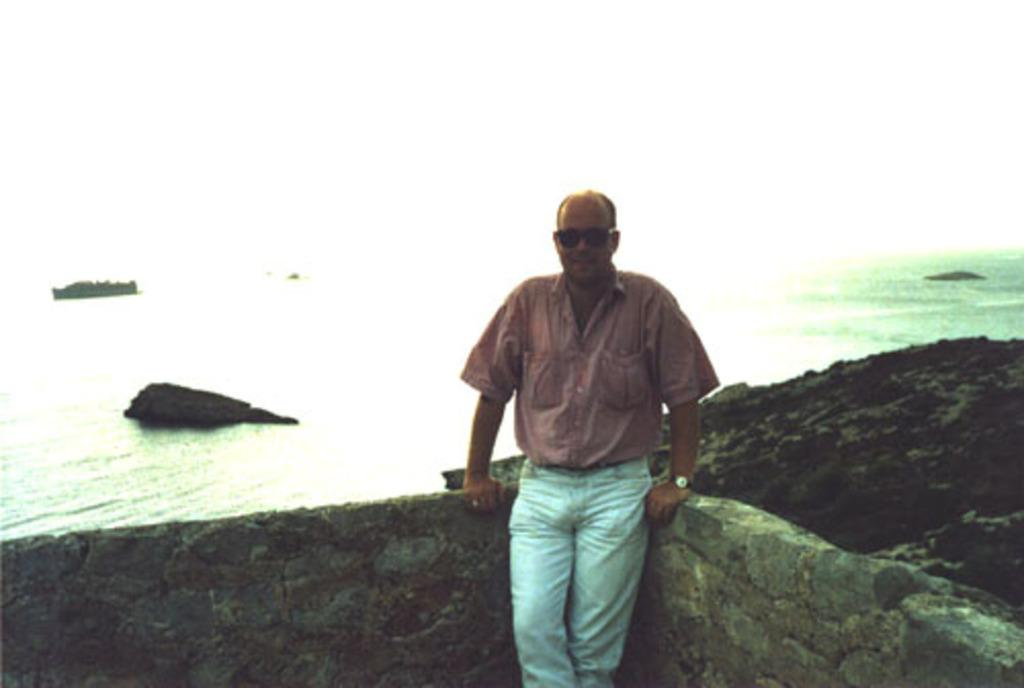Who is present in the image? There is a man standing in the image. What is the man standing on? The man is standing on a path. What type of structures can be seen in the image? There are walls visible in the image. What natural elements can be seen in the image? There are rocks and water visible in the image. What type of honey is being served during the meal in the image? There is no meal or honey present in the image; it features a man standing on a path with walls, rocks, and water visible. 